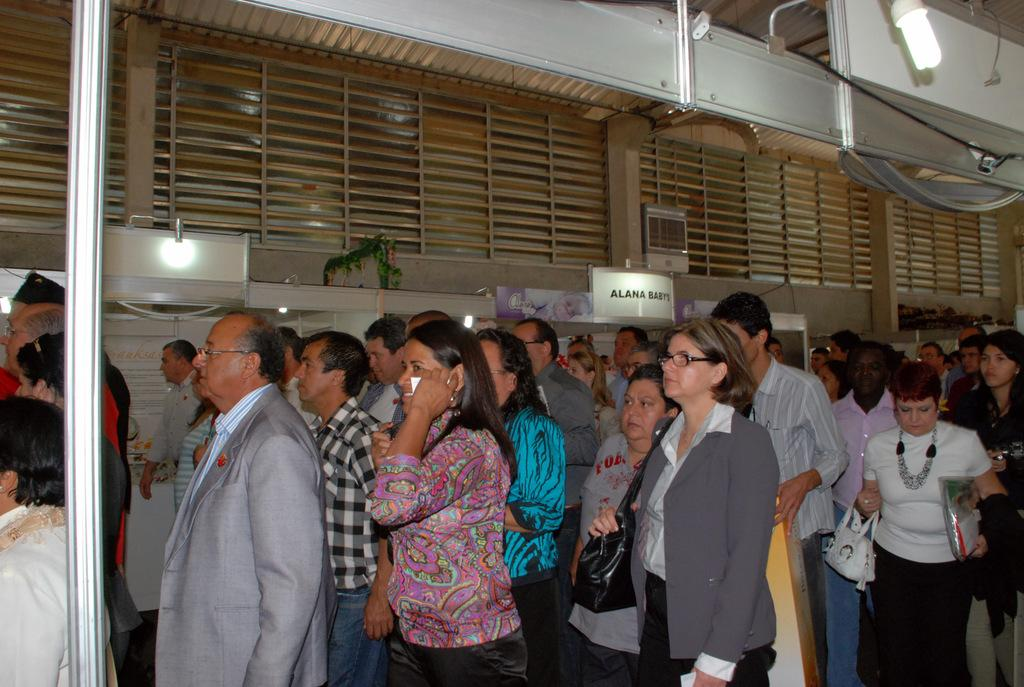What are the people in the image doing? The people in the image are standing in groups. What is attached to the wall in the image? There is a name board attached to the wall in the image. Can you describe the lighting in the image? There is a light in the image. What architectural features can be seen in the image? There are windows and a pole visible in the image. What type of industry can be seen in the image? There is no industry present in the image; it features groups of people standing, a name board, a light, windows, and a pole. How does the dust affect the visibility in the image? There is no mention of dust in the image, so it cannot affect the visibility. 